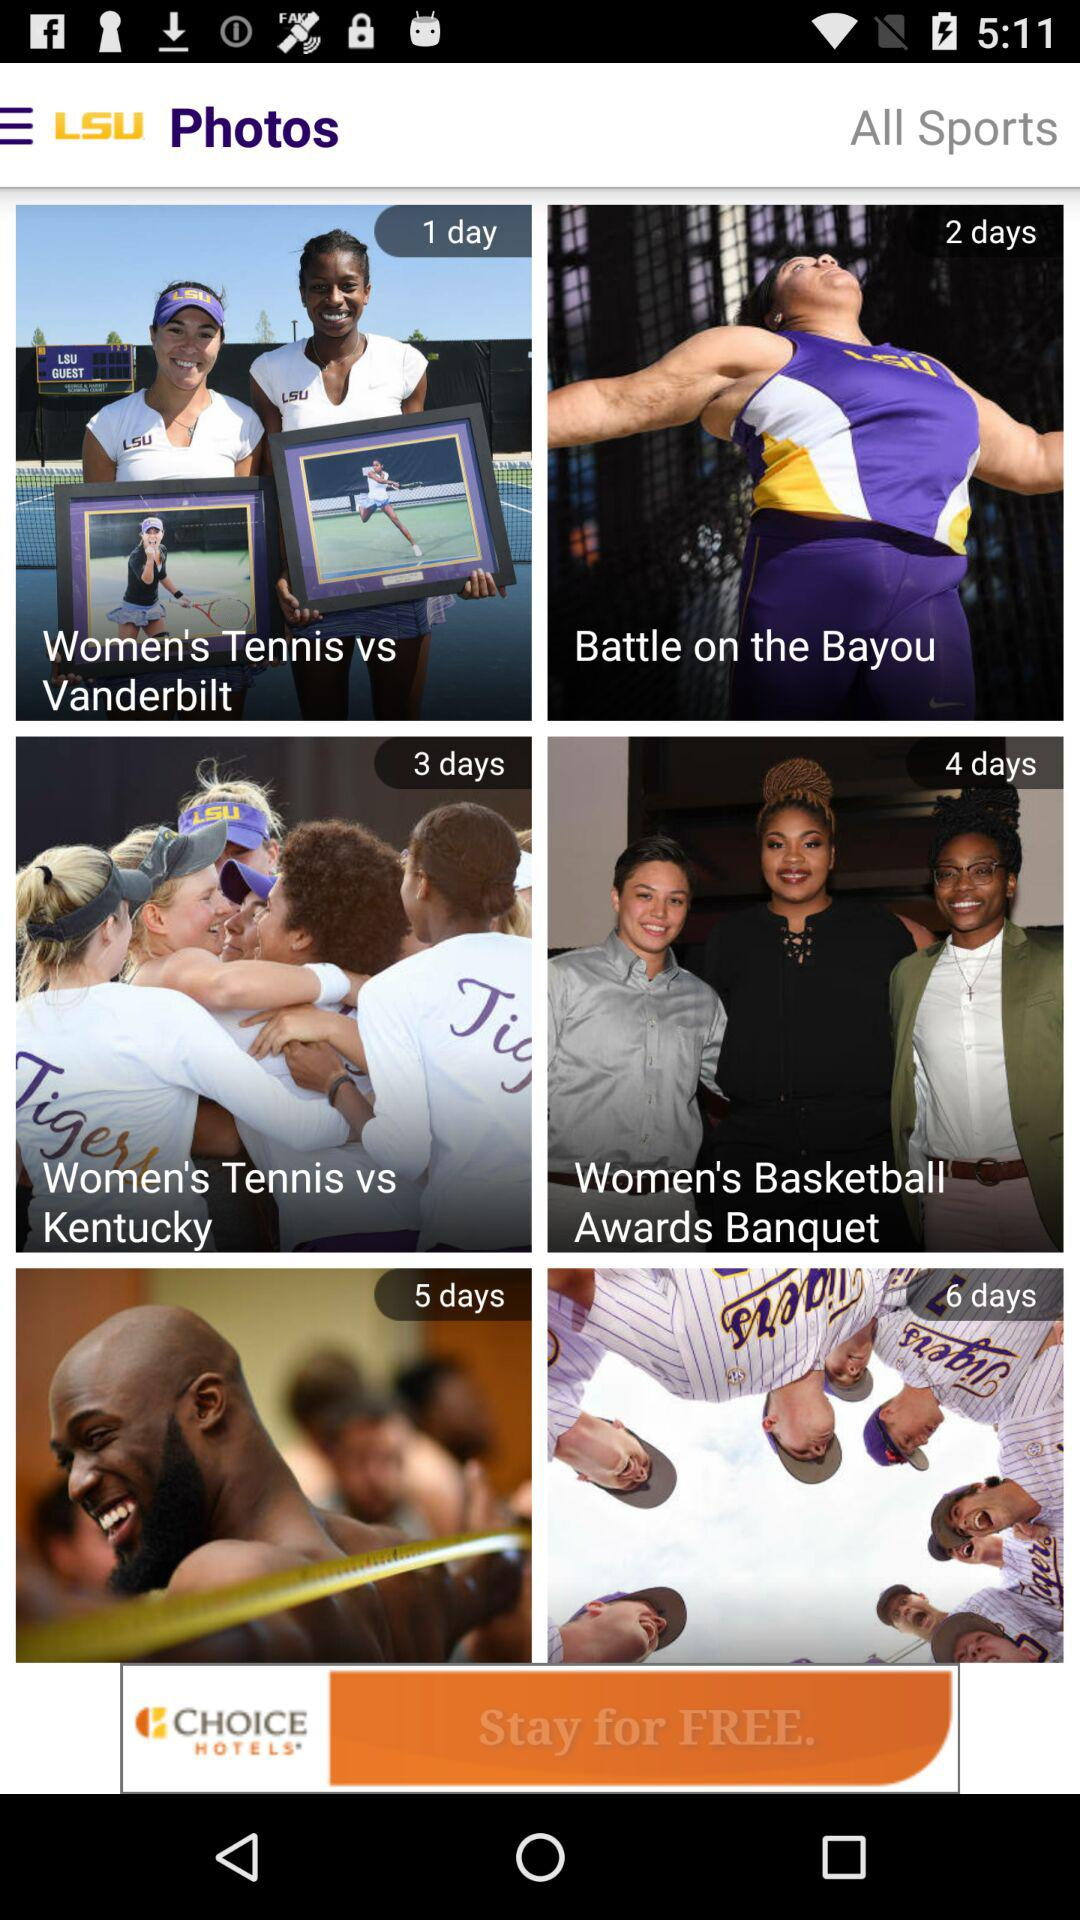What is the name of the application? The name of the application is "LSU Photos". 